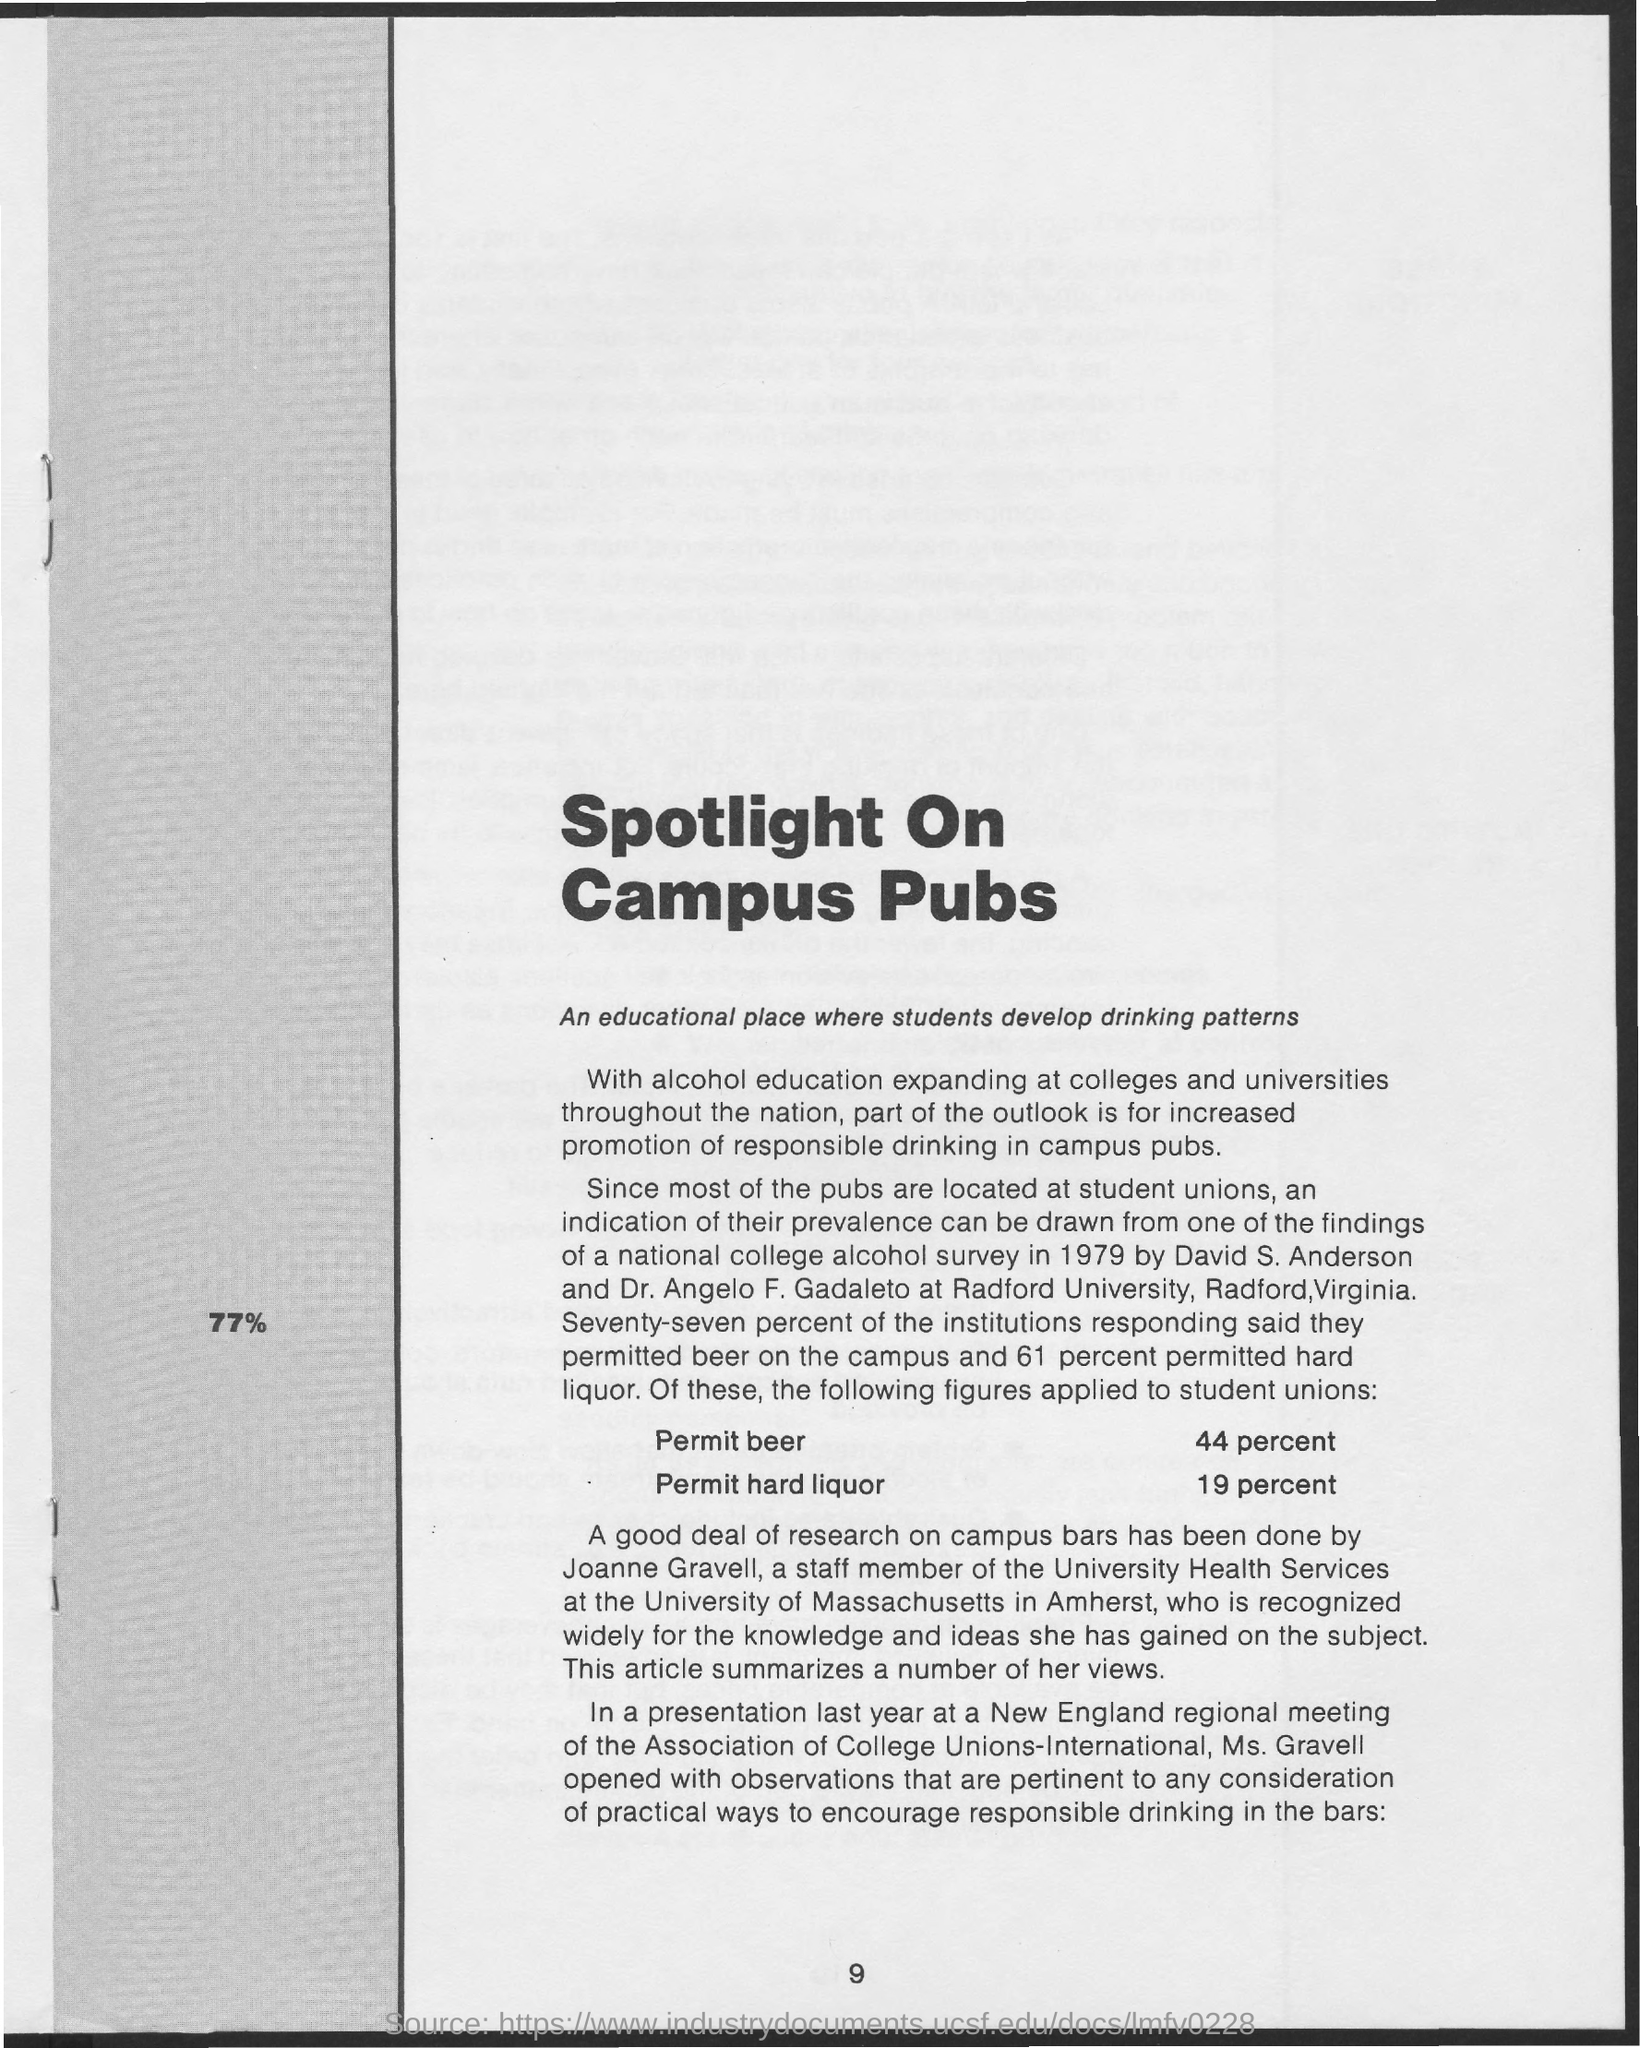What is the page number at bottom of the page?
Give a very brief answer. 9. What is the title of the page?
Keep it short and to the point. Spotlight on Campus Pubs. What is tagline of title spotlight on campus pubs?
Provide a short and direct response. An educational place where students develop drinking patterns. What is the permit percentage of beer?
Give a very brief answer. 44 percent. What is the permit percentage of hard liquor?
Your answer should be compact. 19 percent. 